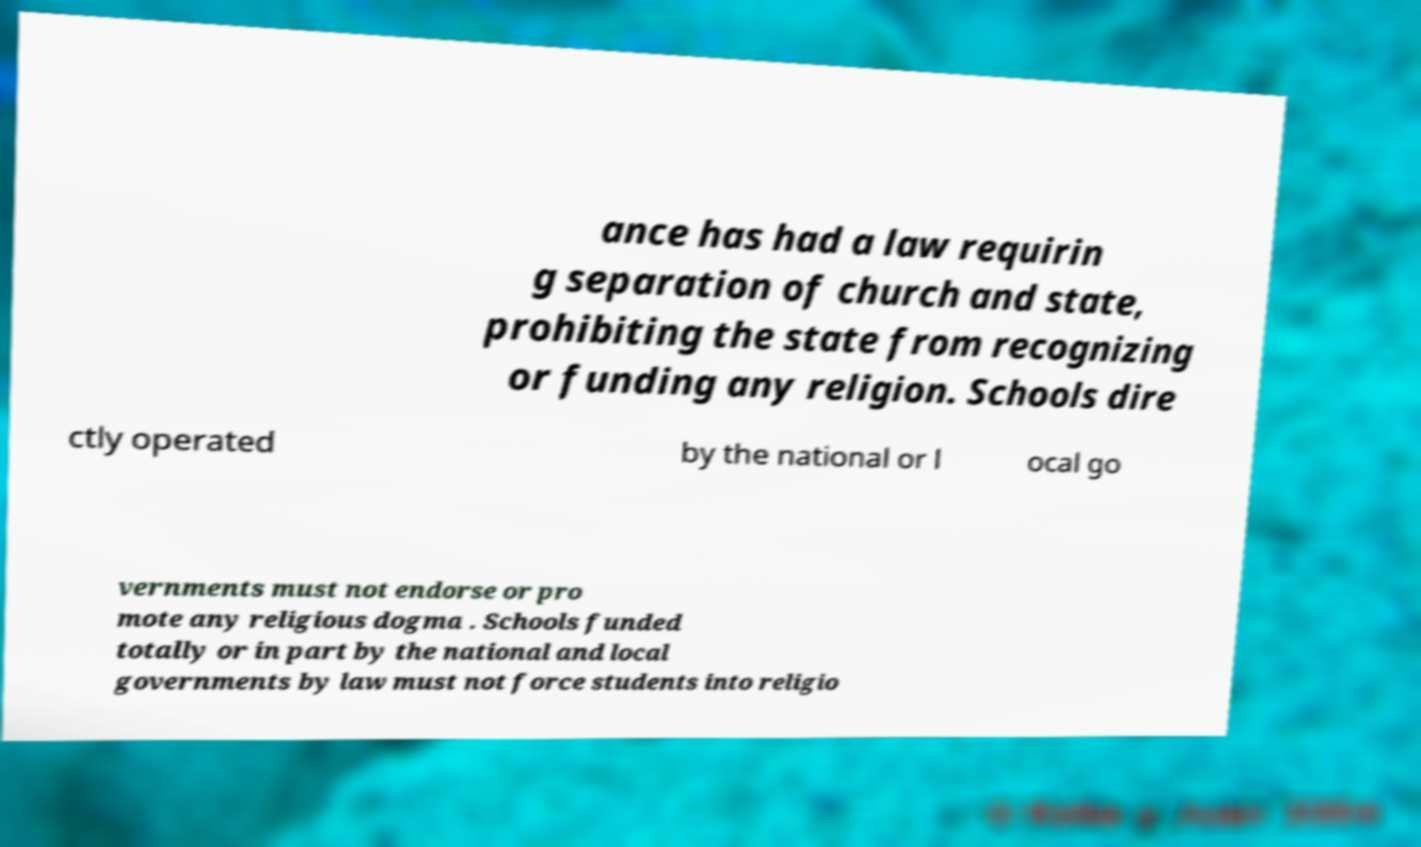For documentation purposes, I need the text within this image transcribed. Could you provide that? ance has had a law requirin g separation of church and state, prohibiting the state from recognizing or funding any religion. Schools dire ctly operated by the national or l ocal go vernments must not endorse or pro mote any religious dogma . Schools funded totally or in part by the national and local governments by law must not force students into religio 